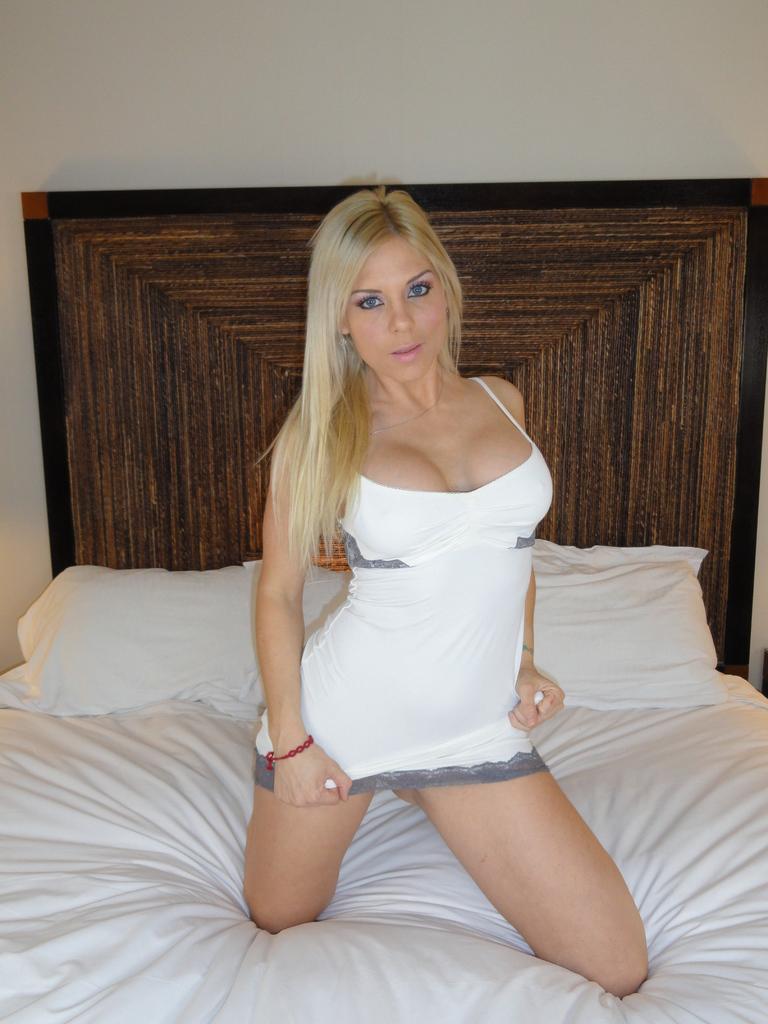Describe this image in one or two sentences. The lady wearing white dress is sitting on a white bed. 